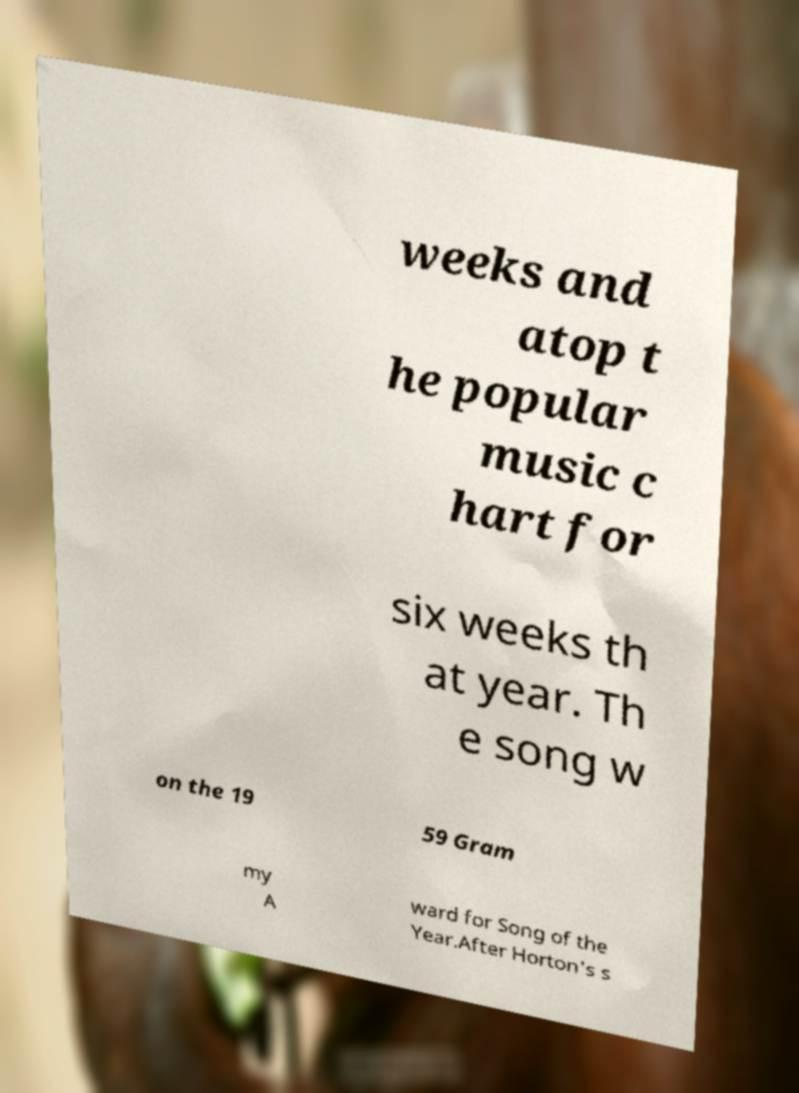For documentation purposes, I need the text within this image transcribed. Could you provide that? weeks and atop t he popular music c hart for six weeks th at year. Th e song w on the 19 59 Gram my A ward for Song of the Year.After Horton's s 